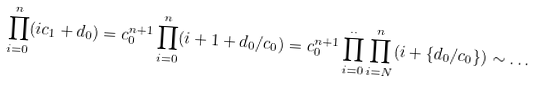Convert formula to latex. <formula><loc_0><loc_0><loc_500><loc_500>\prod _ { i = 0 } ^ { n } ( i c _ { 1 } + d _ { 0 } ) = c _ { 0 } ^ { n + 1 } \prod _ { i = 0 } ^ { n } ( i + 1 + d _ { 0 } / c _ { 0 } ) = c _ { 0 } ^ { n + 1 } \prod _ { i = 0 } ^ { . . } \prod _ { i = N } ^ { n } ( i + \{ d _ { 0 } / c _ { 0 } \} ) \sim \dots</formula> 